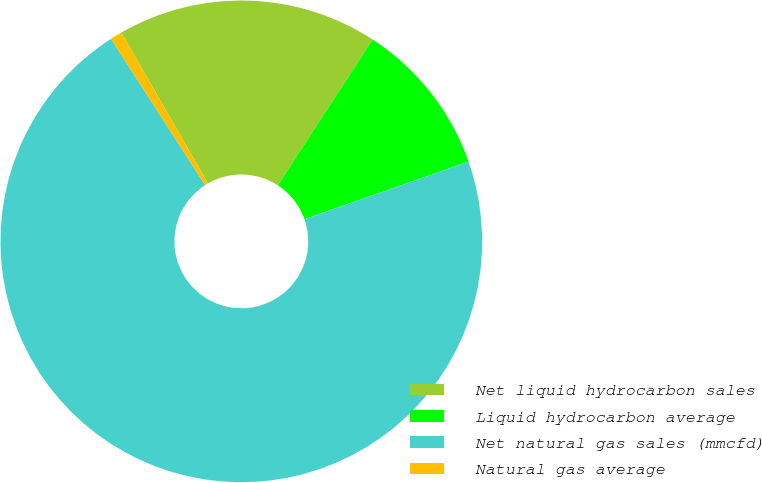Convert chart. <chart><loc_0><loc_0><loc_500><loc_500><pie_chart><fcel>Net liquid hydrocarbon sales<fcel>Liquid hydrocarbon average<fcel>Net natural gas sales (mmcfd)<fcel>Natural gas average<nl><fcel>17.49%<fcel>10.45%<fcel>71.27%<fcel>0.79%<nl></chart> 